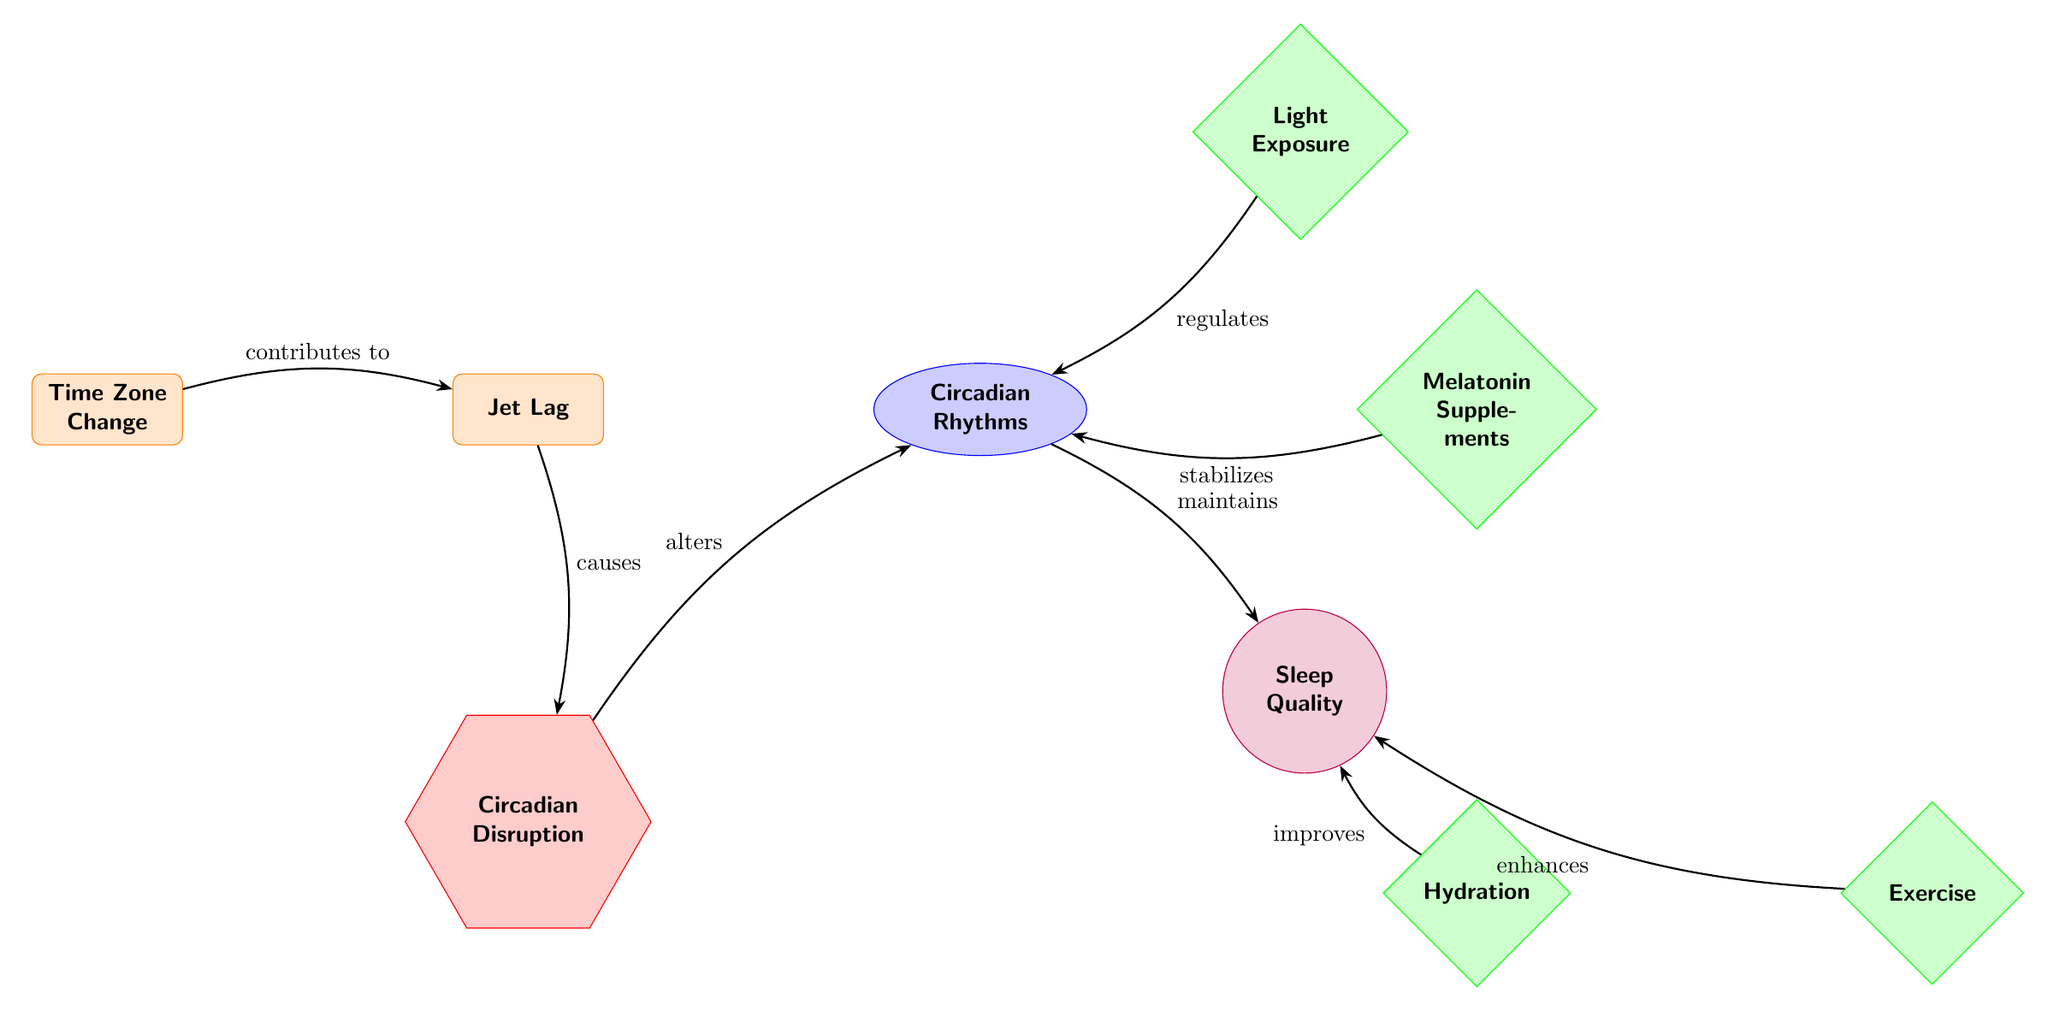What causes Circadian Disruption? According to the diagram, Jet Lag is shown to cause Circadian Disruption, as indicated by the arrow labeled "causes" that connects these two factors.
Answer: Jet Lag How many interventions are listed in the diagram? The diagram includes three interventions: Light Exposure, Melatonin Supplements, and Hydration. By counting these nodes directly, we can determine the total number.
Answer: 3 What improves Sleep Quality according to the diagram? The diagram states that both Hydration and Exercise improve Sleep Quality, as illustrated by the arrows labeled "improves" and "enhances".
Answer: Hydration, Exercise Which factor contributes to Jet Lag? The diagram indicates that Time Zone Change contributes to Jet Lag, verified by the arrow labeled "contributes to" leading from Time Zone Change to Jet Lag.
Answer: Time Zone Change What regulates Circadian Rhythms? Light Exposure is shown to regulate Circadian Rhythms, as presented in the diagram with an arrow labeled "regulates" pointing from Light Exposure to Circadian Rhythms.
Answer: Light Exposure What is the relationship between Circadian Disruption and Circadian Rhythms? The diagram illustrates that Circadian Disruption alters Circadian Rhythms, identified by the arrow labeled "alters" connecting these two nodes.
Answer: Alters Which intervention stabilizes Circadian Rhythms? The diagram specifies that Melatonin Supplements stabilize Circadian Rhythms, as indicated by the arrow labeled "stabilizes" that leads from Melatonin Supplements to Circadian Rhythms.
Answer: Melatonin Supplements What is the outcome of Circadian Rhythms maintaining Sleep Quality? According to the diagram, the relationship established by the arrow labeled "maintains" suggests that Circadian Rhythms maintain Sleep Quality. This asserts that a proper regulation of Circadian Rhythms contributes positively to Sleep Quality.
Answer: Sleep Quality 